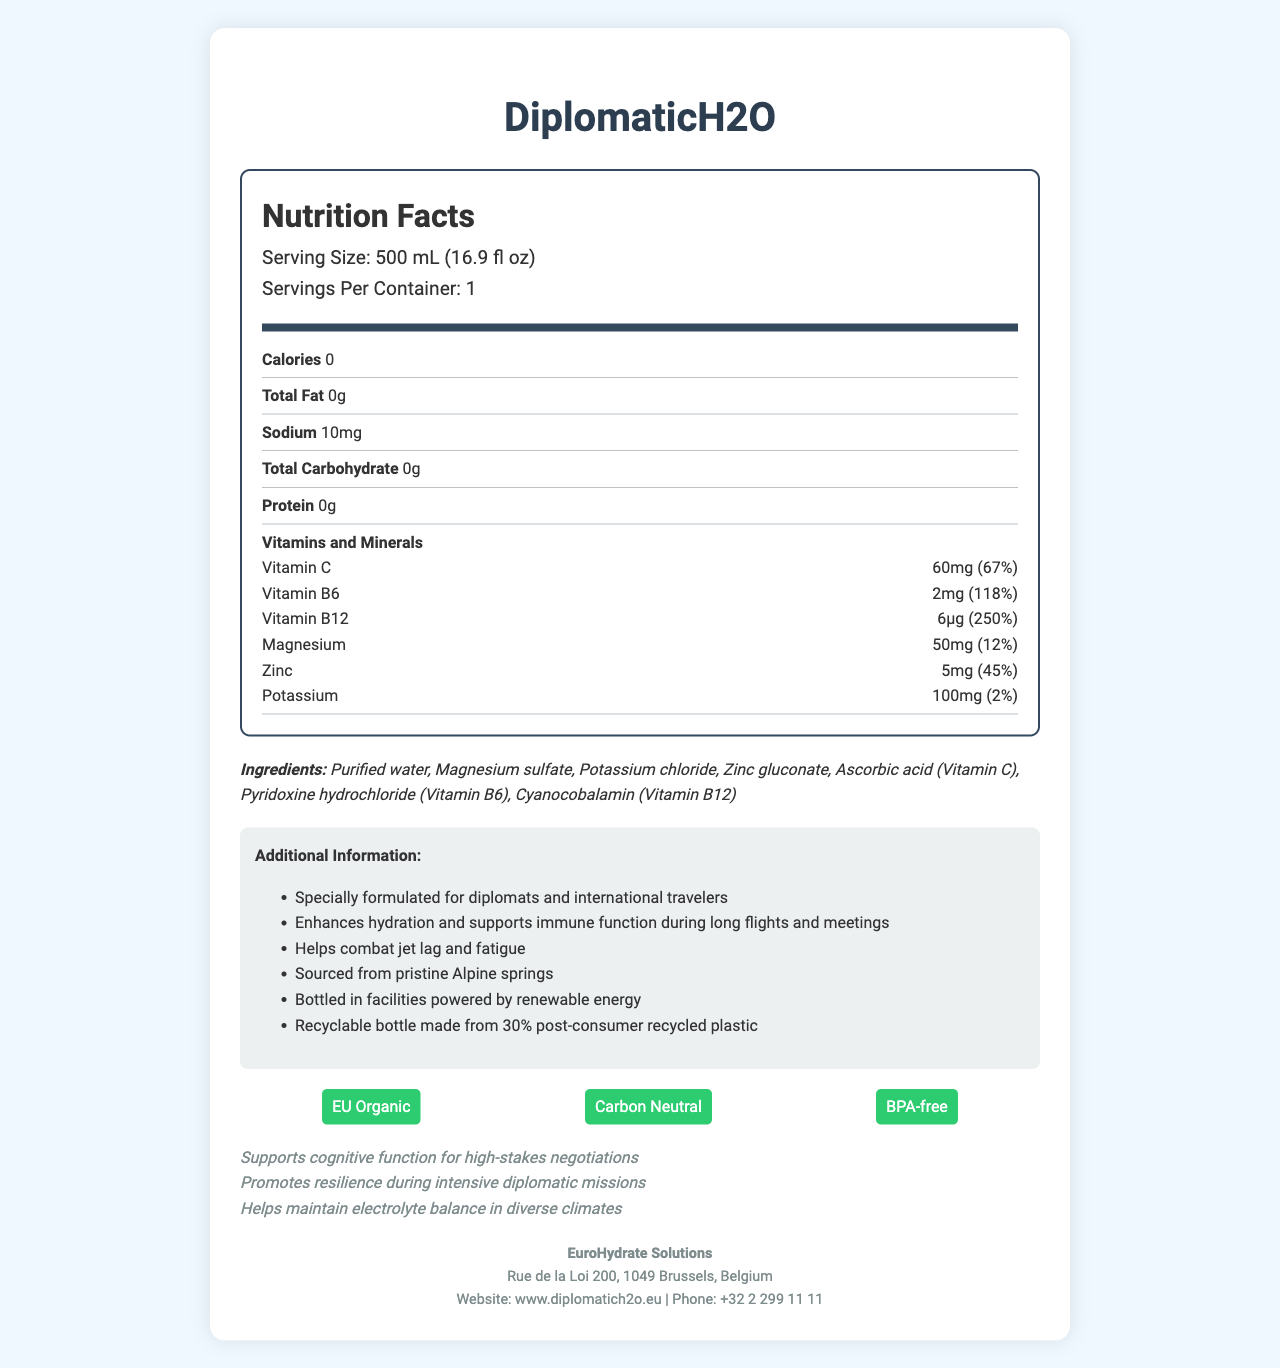what is the serving size? The serving size is listed under the "Serving Size" section in the nutrition label.
Answer: 500 mL (16.9 fl oz) how many calories are there per serving? The number of calories per serving is listed as 0 in the nutrition information.
Answer: 0 what is the daily value percentage for Vitamin B6? The daily value percentage for Vitamin B6 is listed as 118% in the vitamins and minerals section.
Answer: 118% which ingredient is listed first in the ingredients list? The first ingredient listed is Purified water, as seen in the ingredients section.
Answer: Purified water how much sodium is in one serving of DiplomaticH2O? The amount of sodium per serving is 10mg, as listed in the nutrition information.
Answer: 10mg which vitamin has the highest daily value percentage? A. Vitamin C B. Vitamin B6 C. Vitamin B12 D. Magnesium Vitamin B12 has a daily value percentage of 250%, which is the highest among the listed vitamins and minerals.
Answer: C. Vitamin B12 what are the certification labels mentioned for the product? A. EU Organic B. Carbon Neutral C. BPA-free D. All of the above The certification labels mentioned include EU Organic, Carbon Neutral, and BPA-free.
Answer: D. All of the above is the bottle recyclable? The additional information section states that the bottle is made from 30% post-consumer recycled plastic and is recyclable.
Answer: Yes summarize the key benefits of DiplomaticH2O. The summary includes the product's target audience, primary benefits related to hydration, immune function, and combatting jet lag, along with its environmental credentials.
Answer: DiplomaticH2O is specially formulated for diplomats and international travelers. It enhances hydration, supports immune function during long flights and meetings, helps combat jet lag and fatigue, and supports cognitive function and resilience during diplomatic missions. It contains essential vitamins and minerals, and is environmentally friendly with certifications like EU Organic and Carbon Neutral. how many grams of protein does this product contain? The nutrition information lists the amount of protein per serving as 0g.
Answer: 0g which company manufactures DiplomaticH2O? The manufacturer listed in the contact information is EuroHydrate Solutions.
Answer: EuroHydrate Solutions can it be determined where the source of the water is? The additional information states that the water is sourced from pristine Alpine springs.
Answer: Yes what specific benefit does the product claim to provide for high-stakes negotiations? One of the marketing claims is that the product supports cognitive function for high-stakes negotiations.
Answer: Supports cognitive function what is the daily value percentage for Zinc? The daily value percentage for Zinc is listed as 45% in the vitamins and minerals section.
Answer: 45% where is the company EuroHydrate Solutions located? The address for EuroHydrate Solutions is provided in the contact information section.
Answer: Rue de la Loi 200, 1049 Brussels, Belgium what is the phone number listed for contact? The contact phone number for EuroHydrate Solutions is provided in the contact information section.
Answer: +32 2 299 11 11 does the product contain added sugars? The document does not provide information about the presence of added sugars.
Answer: Cannot be determined 